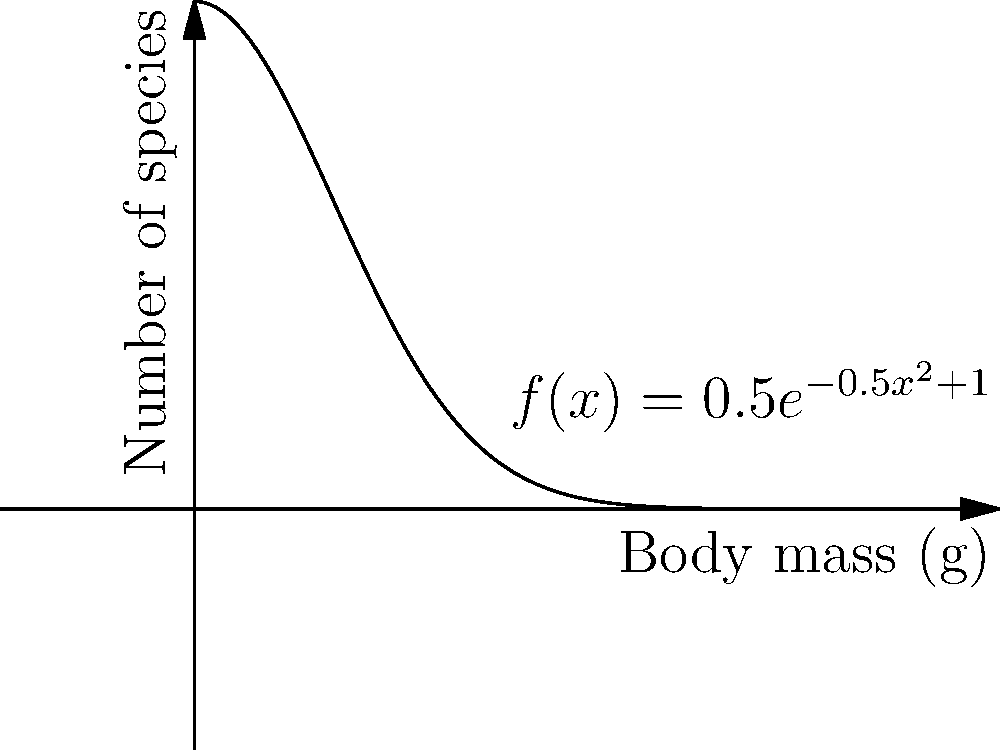The graph represents the distribution of rodent body sizes across different species, where $x$ is the body mass in grams and $f(x)$ is the number of species. The function is given by $f(x) = 0.5e^{-0.5x^2+1}$. Calculate the total number of rodent species with body masses between 0 and 5 grams. To find the total number of rodent species with body masses between 0 and 5 grams, we need to calculate the area under the curve from 0 to 5. This can be done using a definite integral:

1) Set up the integral:
   $$\int_0^5 f(x) dx = \int_0^5 0.5e^{-0.5x^2+1} dx$$

2) This integral cannot be solved analytically, so we need to use numerical integration methods. We can use the trapezoidal rule or Simpson's rule for a good approximation.

3) Using a calculator or computer software with numerical integration capabilities:
   $$\int_0^5 0.5e^{-0.5x^2+1} dx \approx 1.7724$$

4) Interpret the result: The area under the curve represents the total number of rodent species with body masses between 0 and 5 grams.
Answer: Approximately 1.7724 species 